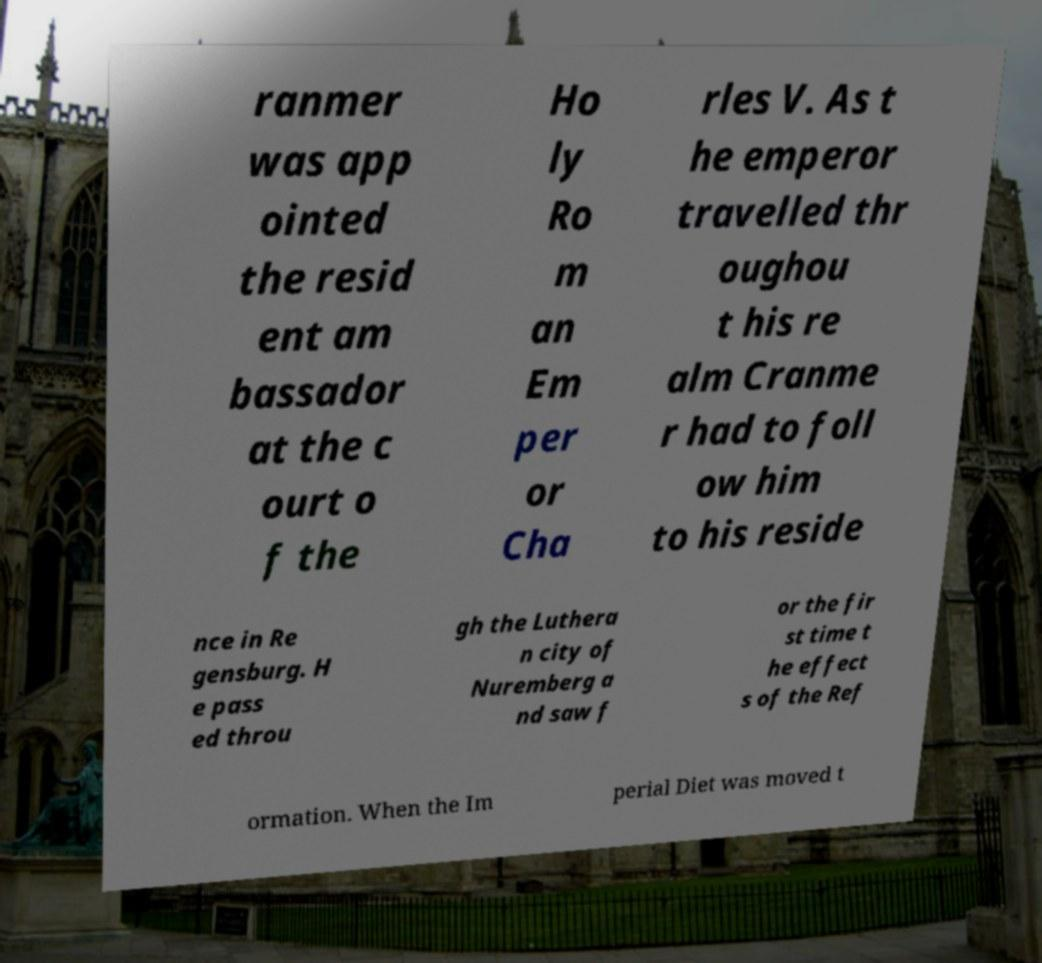I need the written content from this picture converted into text. Can you do that? ranmer was app ointed the resid ent am bassador at the c ourt o f the Ho ly Ro m an Em per or Cha rles V. As t he emperor travelled thr oughou t his re alm Cranme r had to foll ow him to his reside nce in Re gensburg. H e pass ed throu gh the Luthera n city of Nuremberg a nd saw f or the fir st time t he effect s of the Ref ormation. When the Im perial Diet was moved t 